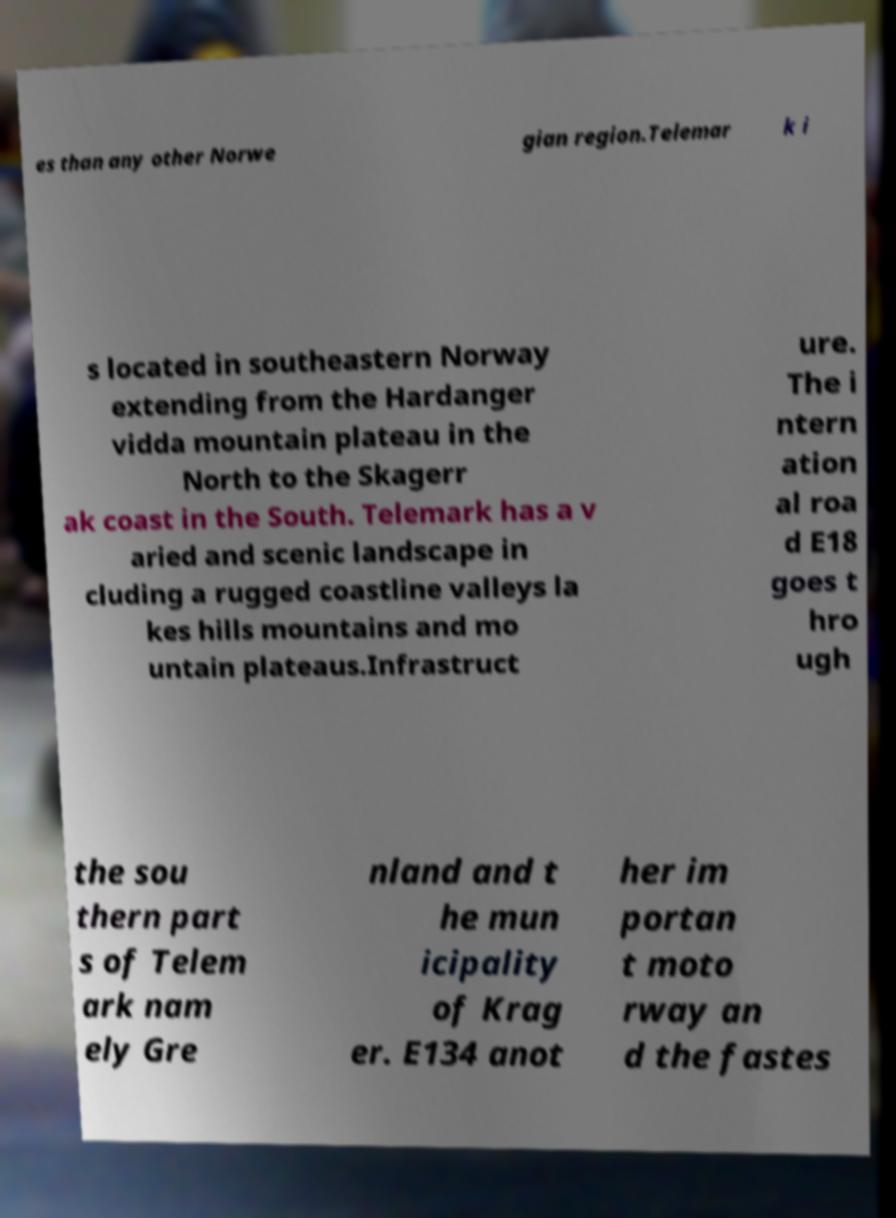Could you extract and type out the text from this image? es than any other Norwe gian region.Telemar k i s located in southeastern Norway extending from the Hardanger vidda mountain plateau in the North to the Skagerr ak coast in the South. Telemark has a v aried and scenic landscape in cluding a rugged coastline valleys la kes hills mountains and mo untain plateaus.Infrastruct ure. The i ntern ation al roa d E18 goes t hro ugh the sou thern part s of Telem ark nam ely Gre nland and t he mun icipality of Krag er. E134 anot her im portan t moto rway an d the fastes 